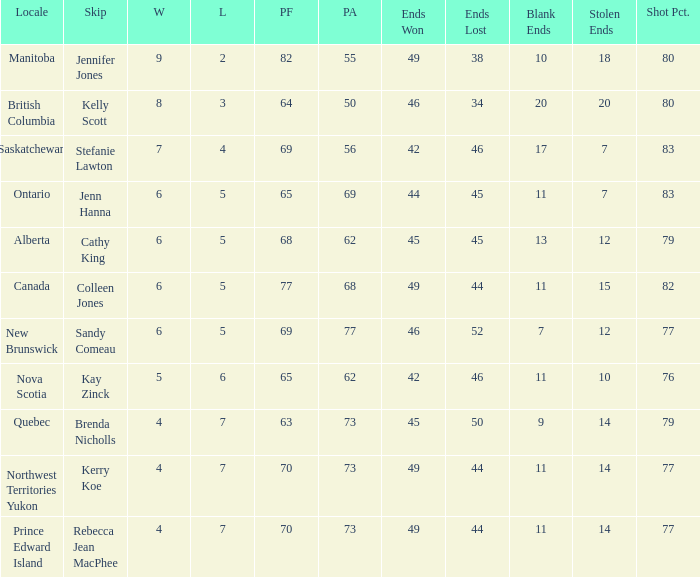What is the lowest PF? 63.0. 